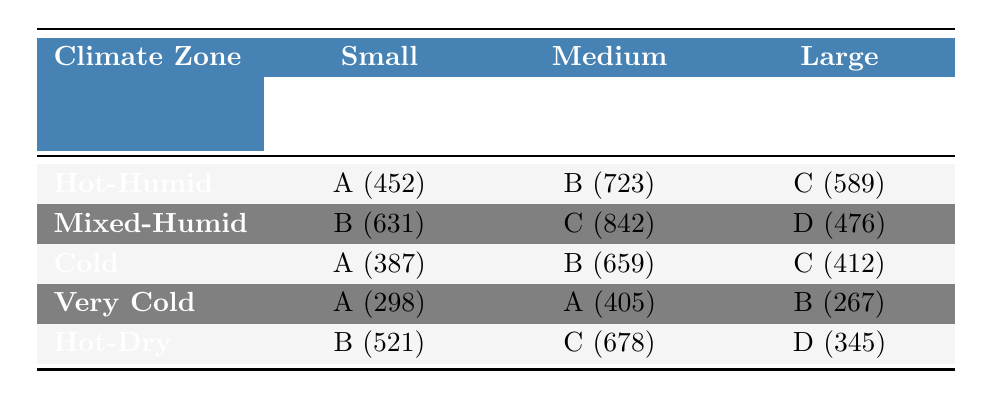What is the energy efficiency rating for small homes in the Hot-Humid climate zone? In the Hot-Humid climate zone, small homes (< 1,500 sq ft) have an energy efficiency rating of A, with a count of 452.
Answer: A How many medium-sized homes in the Cold climate zone have a B rating? The Cold climate zone has medium-sized homes (1,500 - 2,500 sq ft) with an energy efficiency rating of B, totaling 659.
Answer: 659 Which climate zone has the highest number of large homes with a D rating? The Hot-Dry climate zone has large homes (> 2,500 sq ft) with an energy efficiency rating of D, totaling 345; other climate zones do not exceed this for large homes and D rating.
Answer: Hot-Dry What is the total count of small homes rated A across all climate zones? The counts of small homes rated A are: Hot-Humid (452), Cold (387), and Very Cold (298). Total sum: 452 + 387 + 298 = 1137.
Answer: 1137 Which home size in the Mixed-Humid climate zone has the lowest energy efficiency rating? The Mixed-Humid climate zone lists a large home (> 2,500 sq ft) with a rating of D, which is lower than the ratings for small (B) and medium (C) homes.
Answer: Large home How many small homes are there in total across all climate zones? The counts of small homes are: Hot-Humid (452), Mixed-Humid (631), Cold (387), Very Cold (298), and Hot-Dry (521). Adding these gives 452 + 631 + 387 + 298 + 521 = 2289.
Answer: 2289 Is it true that all climate zones have at least one small home rated A? Yes, the Hot-Humid, Cold, and Very Cold climate zones all have small homes rated A.
Answer: Yes Which climate zone has more medium-sized homes rated C than the Mixed-Humid zone? The Hot-Humid climate zone has medium-sized homes with a rating of B (723), while Mixed-Humid has C (842). The Mixed-Humid zone has more homes rated C than the Hot-Humid zone.
Answer: No What is the difference between the total counts of large homes rated C and D in the Cold and Mixed-Humid zones respectively? Cold zone has large homes rated C (412) and Mixed-Humid has D rated (476). The difference is 476 - 412 = 64.
Answer: 64 Which home size in the Very Cold climate zone has the highest count? The medium-sized homes (1,500 - 2,500 sq ft) in the Very Cold climate zone with a rating of A has a count of 405, which is higher than the count of small (298) or large (267) homes.
Answer: Medium homes 